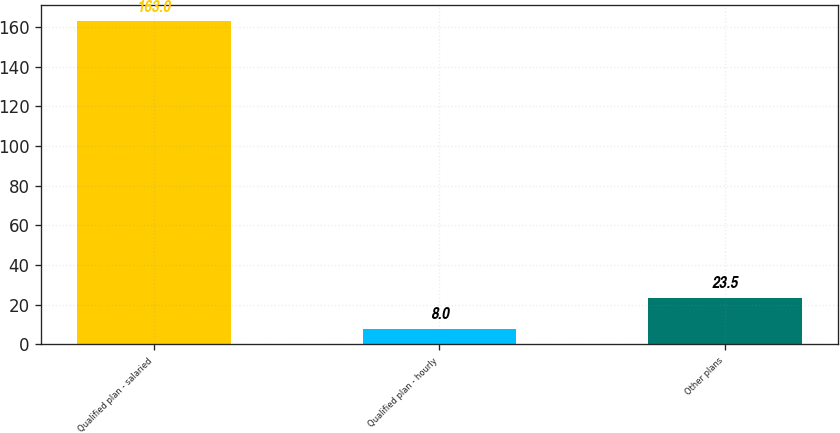Convert chart. <chart><loc_0><loc_0><loc_500><loc_500><bar_chart><fcel>Qualified plan - salaried<fcel>Qualified plan - hourly<fcel>Other plans<nl><fcel>163<fcel>8<fcel>23.5<nl></chart> 